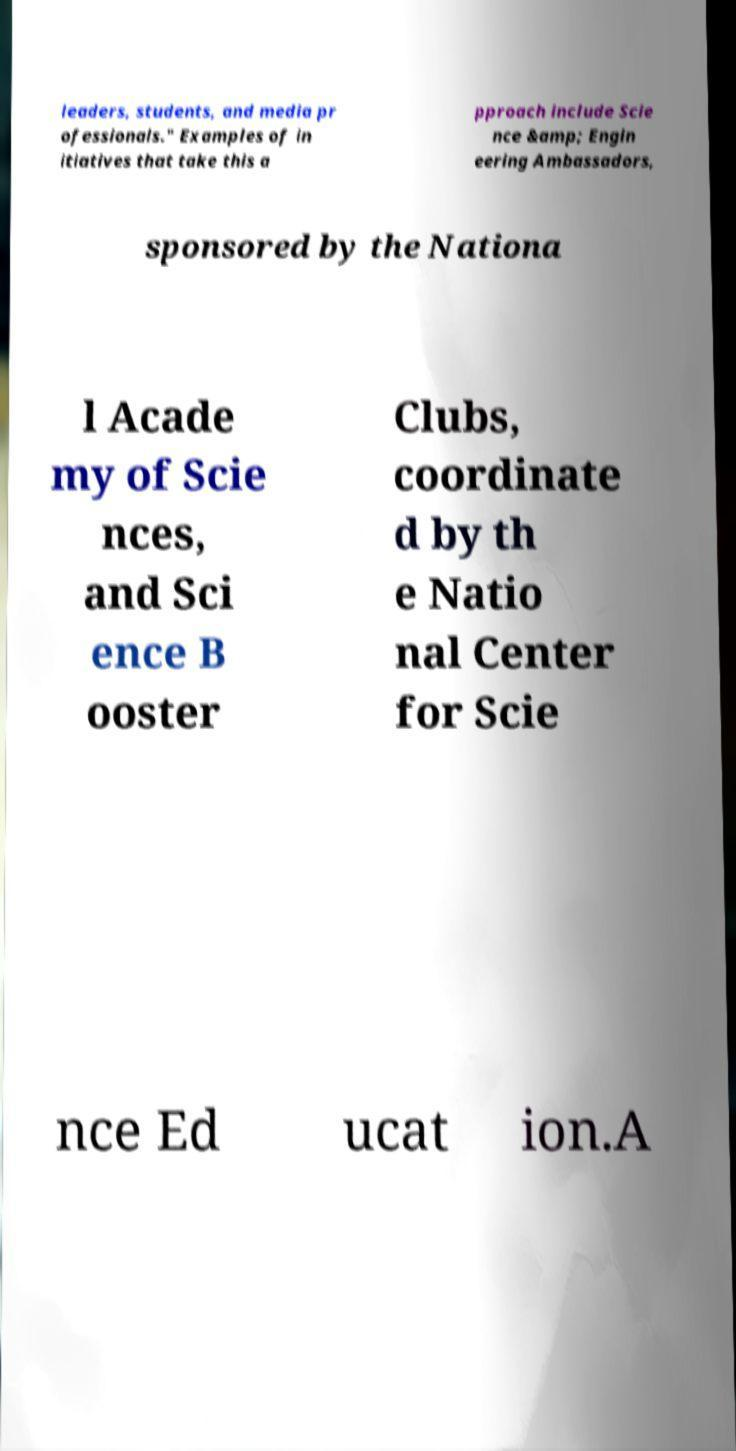I need the written content from this picture converted into text. Can you do that? leaders, students, and media pr ofessionals." Examples of in itiatives that take this a pproach include Scie nce &amp; Engin eering Ambassadors, sponsored by the Nationa l Acade my of Scie nces, and Sci ence B ooster Clubs, coordinate d by th e Natio nal Center for Scie nce Ed ucat ion.A 